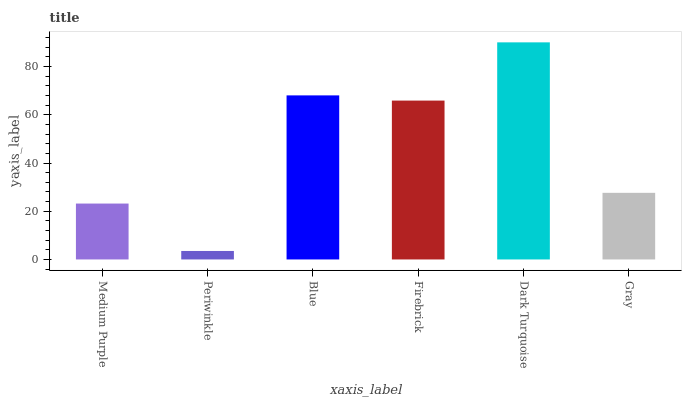Is Blue the minimum?
Answer yes or no. No. Is Blue the maximum?
Answer yes or no. No. Is Blue greater than Periwinkle?
Answer yes or no. Yes. Is Periwinkle less than Blue?
Answer yes or no. Yes. Is Periwinkle greater than Blue?
Answer yes or no. No. Is Blue less than Periwinkle?
Answer yes or no. No. Is Firebrick the high median?
Answer yes or no. Yes. Is Gray the low median?
Answer yes or no. Yes. Is Blue the high median?
Answer yes or no. No. Is Periwinkle the low median?
Answer yes or no. No. 